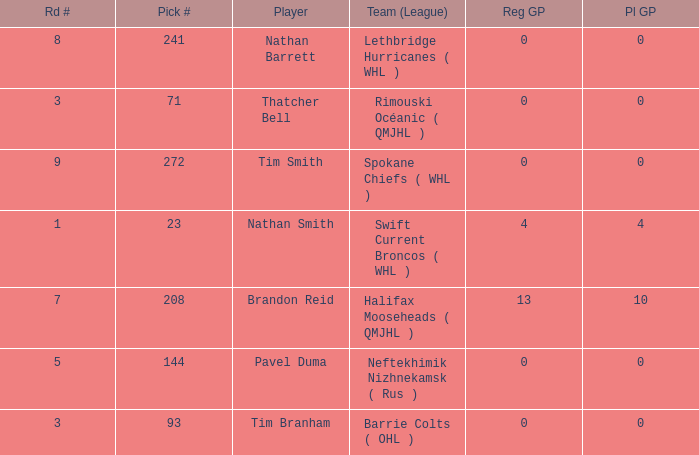I'm looking to parse the entire table for insights. Could you assist me with that? {'header': ['Rd #', 'Pick #', 'Player', 'Team (League)', 'Reg GP', 'Pl GP'], 'rows': [['8', '241', 'Nathan Barrett', 'Lethbridge Hurricanes ( WHL )', '0', '0'], ['3', '71', 'Thatcher Bell', 'Rimouski Océanic ( QMJHL )', '0', '0'], ['9', '272', 'Tim Smith', 'Spokane Chiefs ( WHL )', '0', '0'], ['1', '23', 'Nathan Smith', 'Swift Current Broncos ( WHL )', '4', '4'], ['7', '208', 'Brandon Reid', 'Halifax Mooseheads ( QMJHL )', '13', '10'], ['5', '144', 'Pavel Duma', 'Neftekhimik Nizhnekamsk ( Rus )', '0', '0'], ['3', '93', 'Tim Branham', 'Barrie Colts ( OHL )', '0', '0']]} How many reg GP for nathan barrett in a round less than 8? 0.0. 